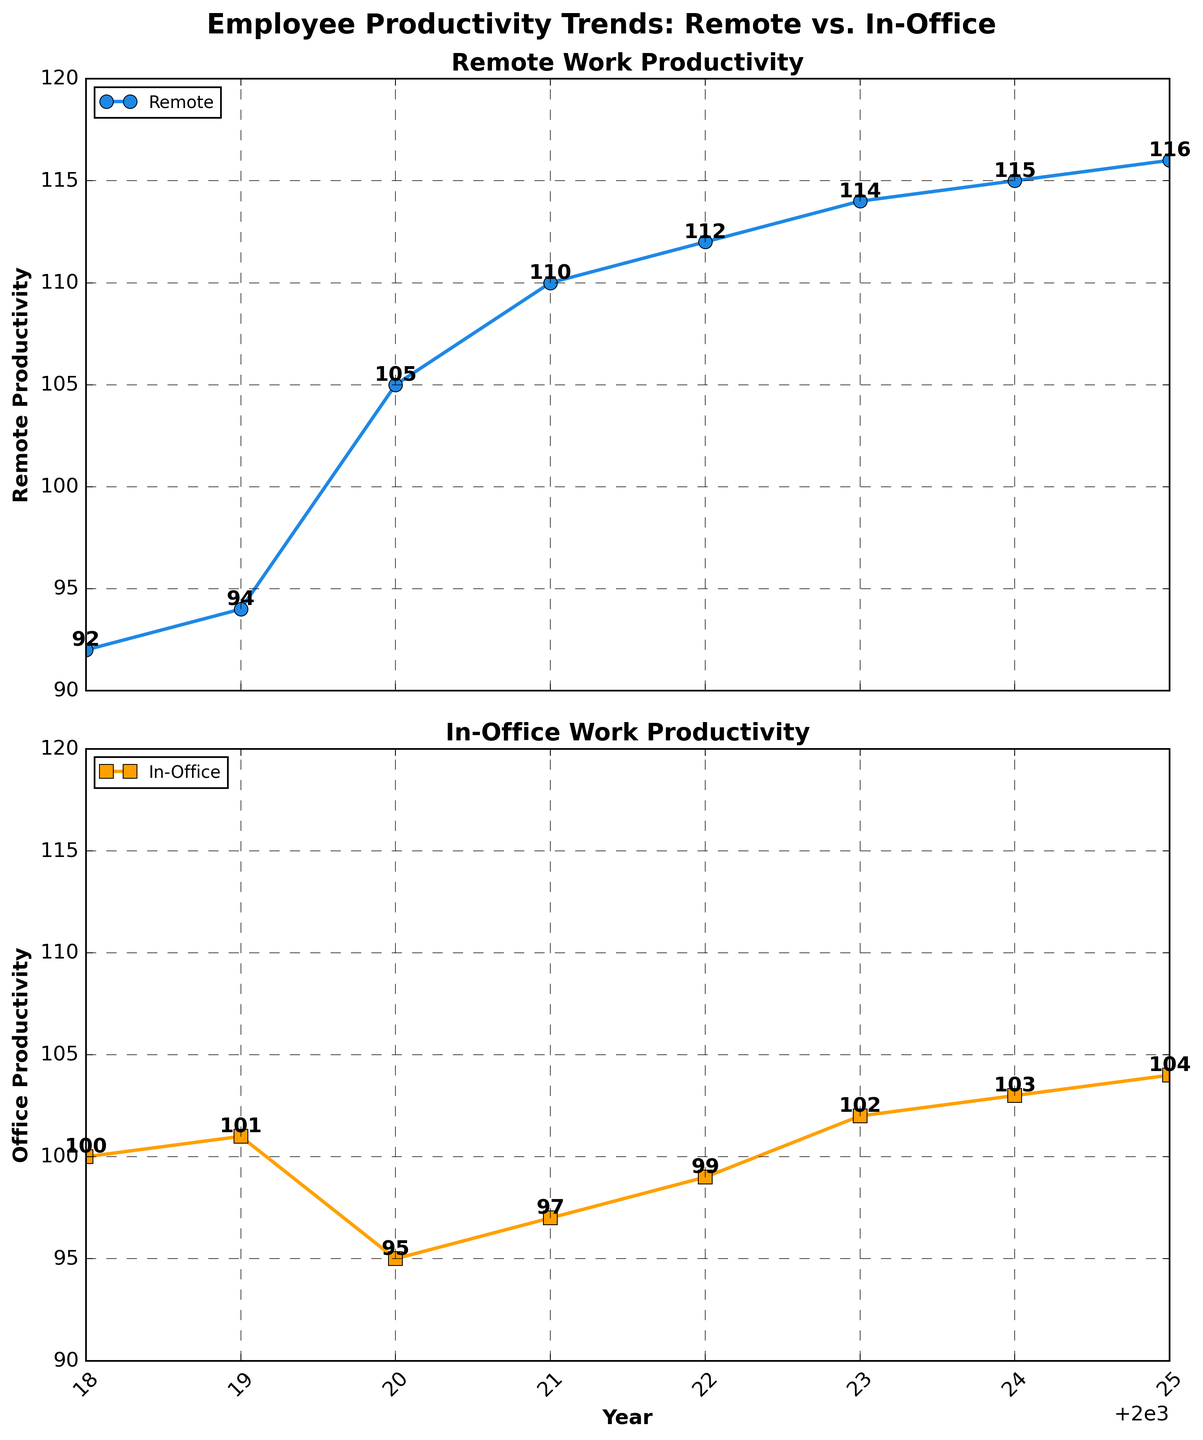What is the general trend of remote productivity from 2018 to 2025? The general trend of remote productivity from 2018 to 2025 is an increase. We see that the productivity value starts at 92 in 2018 and consistently rises each year to reach 116 in 2025.
Answer: An increasing trend How do remote and office productivity compare in 2020? In 2020, remote productivity is 105, while office productivity is 95. Remote productivity is higher than office productivity by 10 units.
Answer: Remote productivity is higher What is the average productivity for remote work over the entire period? To find the average productivity for remote work, sum all the productivity values for remote work and divide by the number of years: \((92 + 94 + 105 + 110 + 112 + 114 + 115 + 116) / 8 = 108.5\).
Answer: 108.5 How does office productivity in 2023 compare to remote productivity in the same year? In 2023, office productivity is 102 and remote productivity is 114. Office productivity is lower than remote productivity by 12 units.
Answer: Lower by 12 units Which year shows the maximum difference between remote and office productivity? To find the year with the maximum difference, subtract office productivity from remote productivity for each year and identify the maximum difference. The differences are: 2018: -8, 2019: -7, 2020: 10, 2021: 13, 2022: 13, 2023: 12, 2024: 12, 2025: 12. The maximum difference is 13, in years 2021 and 2022.
Answer: 2021 and 2022 What is the trend of office productivity from 2018 to 2025? The general trend of office productivity from 2018 to 2025 is an increase with some fluctuations. Starting at 100 in 2018, it shows a slight decrease in 2020 to 95, but then continuously rises to 104 in 2025.
Answer: An increasing trend with fluctuations Is there any year where office productivity decreased from the previous year? Yes, office productivity decreased from the previous year in 2020. It went from 101 in 2019 to 95 in 2020.
Answer: 2020 What is the combined productivity (sum of remote and office) in 2025? The combined productivity in 2025 is the sum of remote and office productivity values for that year: \( 116 + 104 = 220 \).
Answer: 220 Compare the productivity trends of remote and office work in 2021. In 2021, remote productivity shows an increasing trend, rising from 105 in 2020 to 110 in 2021, while office productivity also shows an increase from 95 in 2020 to 97 in 2021. Both are increasing, but remote productivity increased more significantly.
Answer: Both increased, remote more significantly What is the visual difference between the plots of remote and office productivity in terms of markers and colors used? The remote productivity plot uses circle markers and blue lines, while the office productivity plot uses square markers and orange lines.
Answer: Circle markers and blue lines for remote, square markers and orange lines for office 